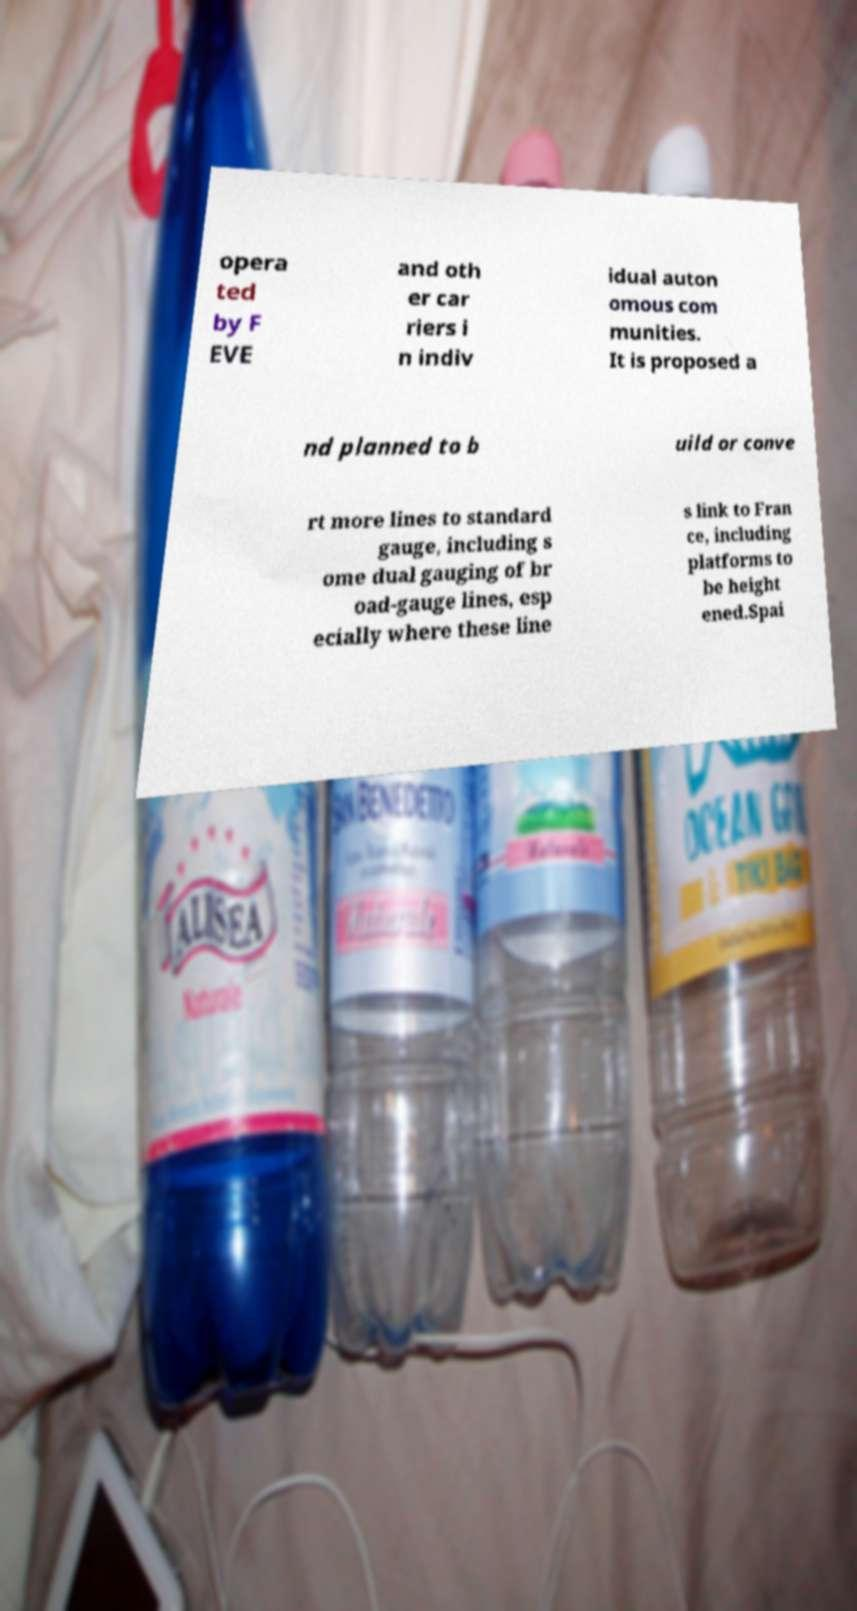I need the written content from this picture converted into text. Can you do that? opera ted by F EVE and oth er car riers i n indiv idual auton omous com munities. It is proposed a nd planned to b uild or conve rt more lines to standard gauge, including s ome dual gauging of br oad-gauge lines, esp ecially where these line s link to Fran ce, including platforms to be height ened.Spai 